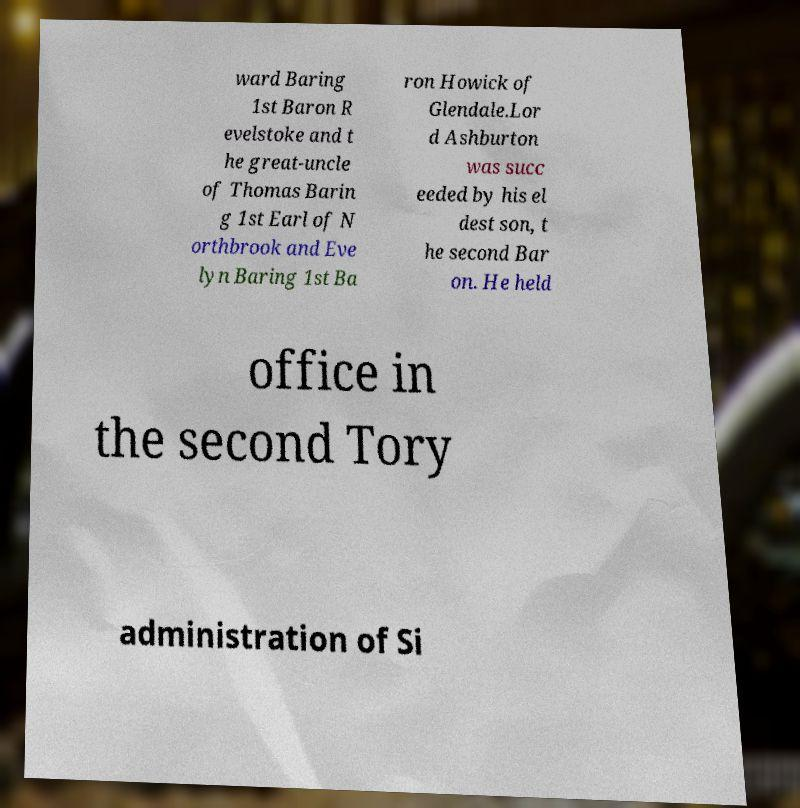Could you assist in decoding the text presented in this image and type it out clearly? ward Baring 1st Baron R evelstoke and t he great-uncle of Thomas Barin g 1st Earl of N orthbrook and Eve lyn Baring 1st Ba ron Howick of Glendale.Lor d Ashburton was succ eeded by his el dest son, t he second Bar on. He held office in the second Tory administration of Si 